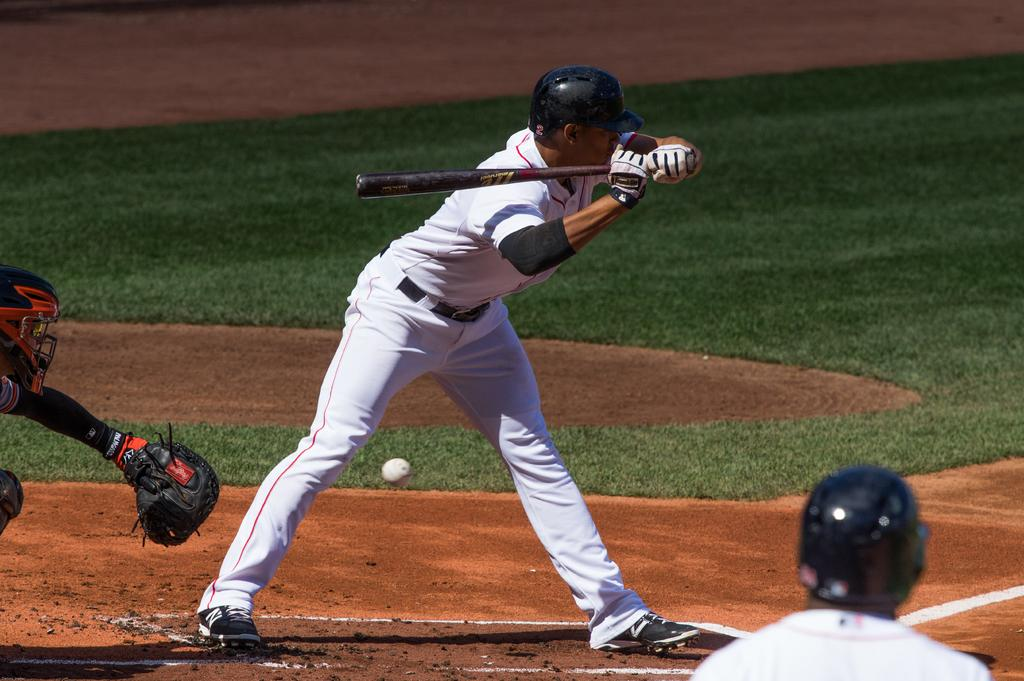What is the person in the image wearing? The person is wearing a white dress. What is the person holding in the image? The person is holding a baseball bat. What action is the person performing? The person is hitting a ball. How many other people are visible in the image? There are two other persons visible in the image. What can be seen in the background of the image? There is a grassland in the background of the image. What type of discussion is taking place between the person and the two others in the image? There is no discussion taking place in the image; the person is hitting a ball with a baseball bat. 